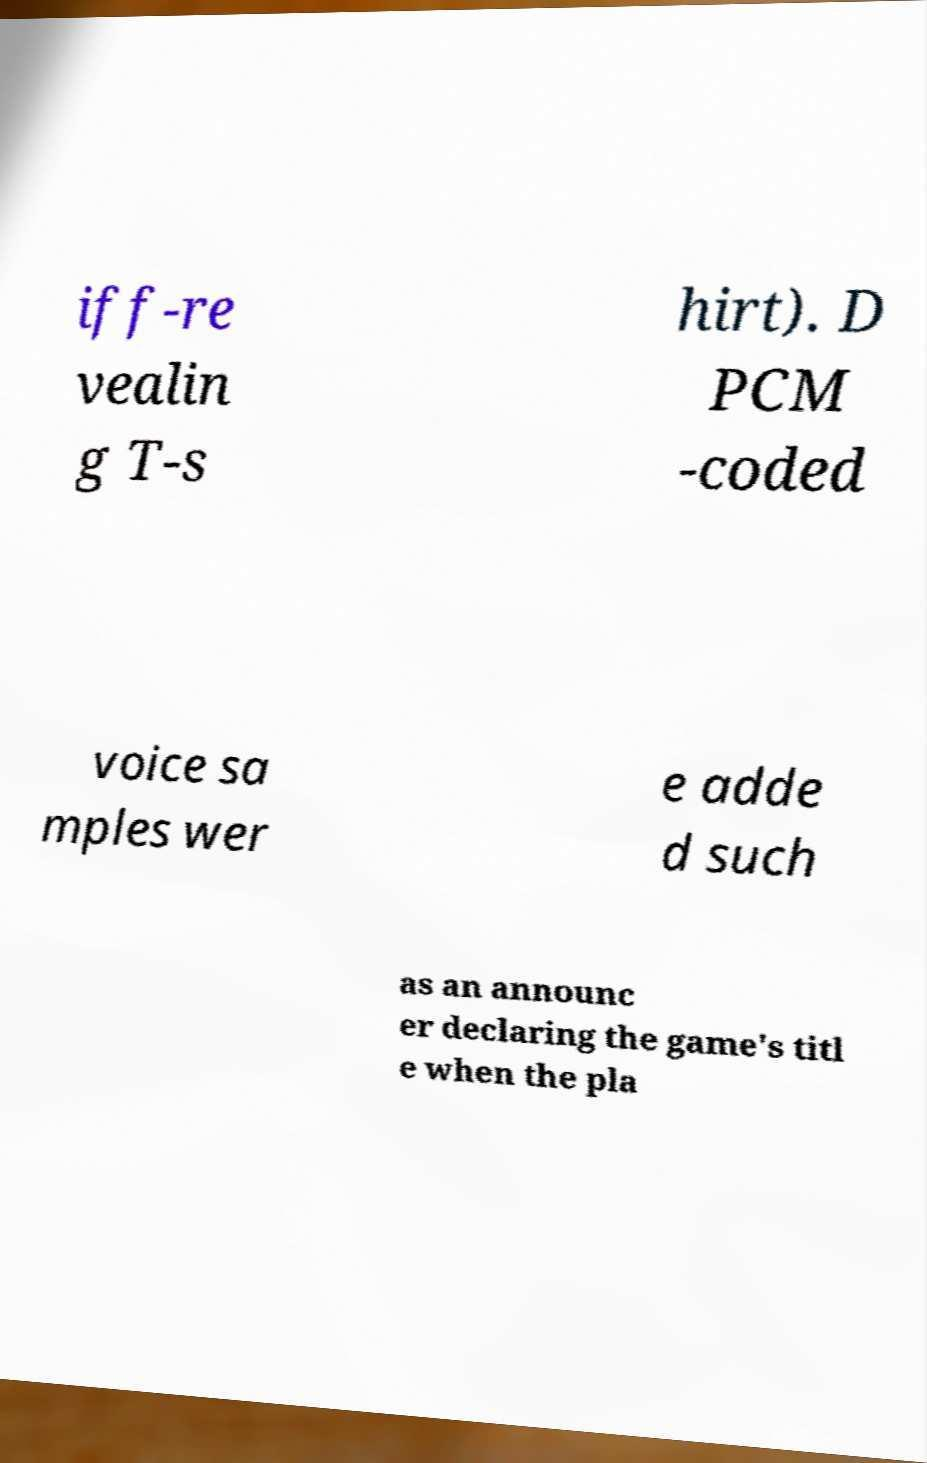There's text embedded in this image that I need extracted. Can you transcribe it verbatim? iff-re vealin g T-s hirt). D PCM -coded voice sa mples wer e adde d such as an announc er declaring the game's titl e when the pla 